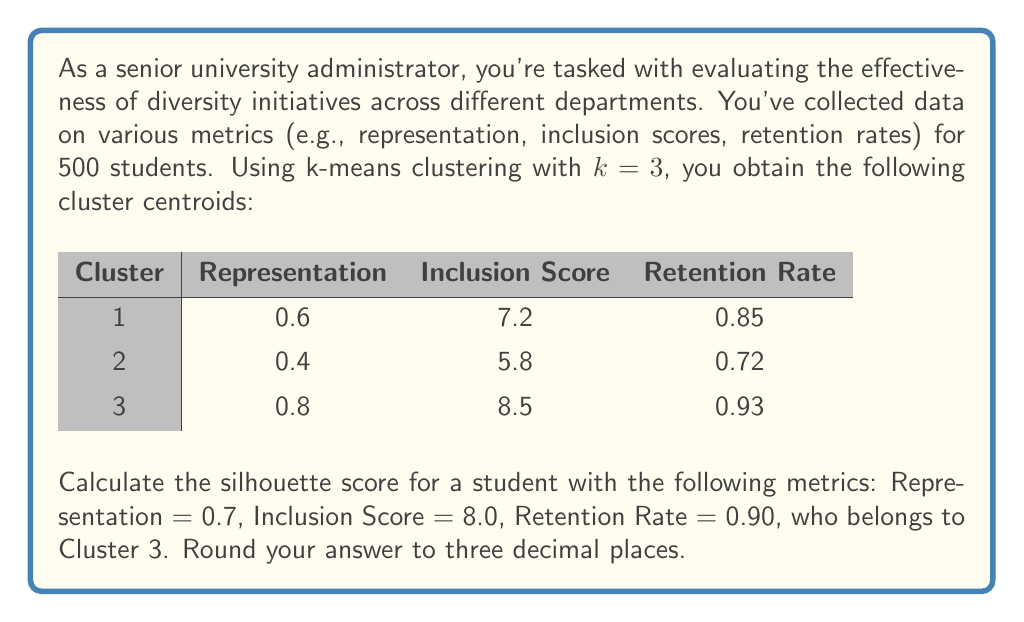Can you solve this math problem? To calculate the silhouette score for the given student, we need to follow these steps:

1. Calculate the average distance (a) between the student and all other points in their cluster (Cluster 3).
2. Calculate the average distance (b) between the student and all points in the nearest neighboring cluster.
3. Compute the silhouette score using the formula: $s = \frac{b-a}{\max(a,b)}$

Step 1: Calculate a
We'll use Euclidean distance. Since we only have the centroid of Cluster 3, we'll use this as an approximation:

$a = \sqrt{(0.7-0.8)^2 + (8.0-8.5)^2 + (0.90-0.93)^2} = 0.5099$

Step 2: Calculate b
We need to find the nearest neighboring cluster. Let's calculate the distance to both Cluster 1 and Cluster 2:

Distance to Cluster 1:
$d_1 = \sqrt{(0.7-0.6)^2 + (8.0-7.2)^2 + (0.90-0.85)^2} = 0.8544$

Distance to Cluster 2:
$d_2 = \sqrt{(0.7-0.4)^2 + (8.0-5.8)^2 + (0.90-0.72)^2} = 2.3324$

Cluster 1 is the nearest neighboring cluster, so $b = 0.8544$

Step 3: Compute the silhouette score
$s = \frac{b-a}{\max(a,b)} = \frac{0.8544 - 0.5099}{\max(0.5099, 0.8544)} = \frac{0.3445}{0.8544} = 0.4032$

Rounding to three decimal places: 0.403
Answer: 0.403 